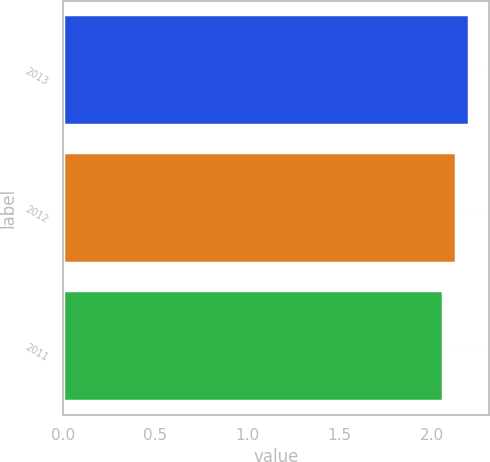Convert chart to OTSL. <chart><loc_0><loc_0><loc_500><loc_500><bar_chart><fcel>2013<fcel>2012<fcel>2011<nl><fcel>2.2<fcel>2.13<fcel>2.06<nl></chart> 